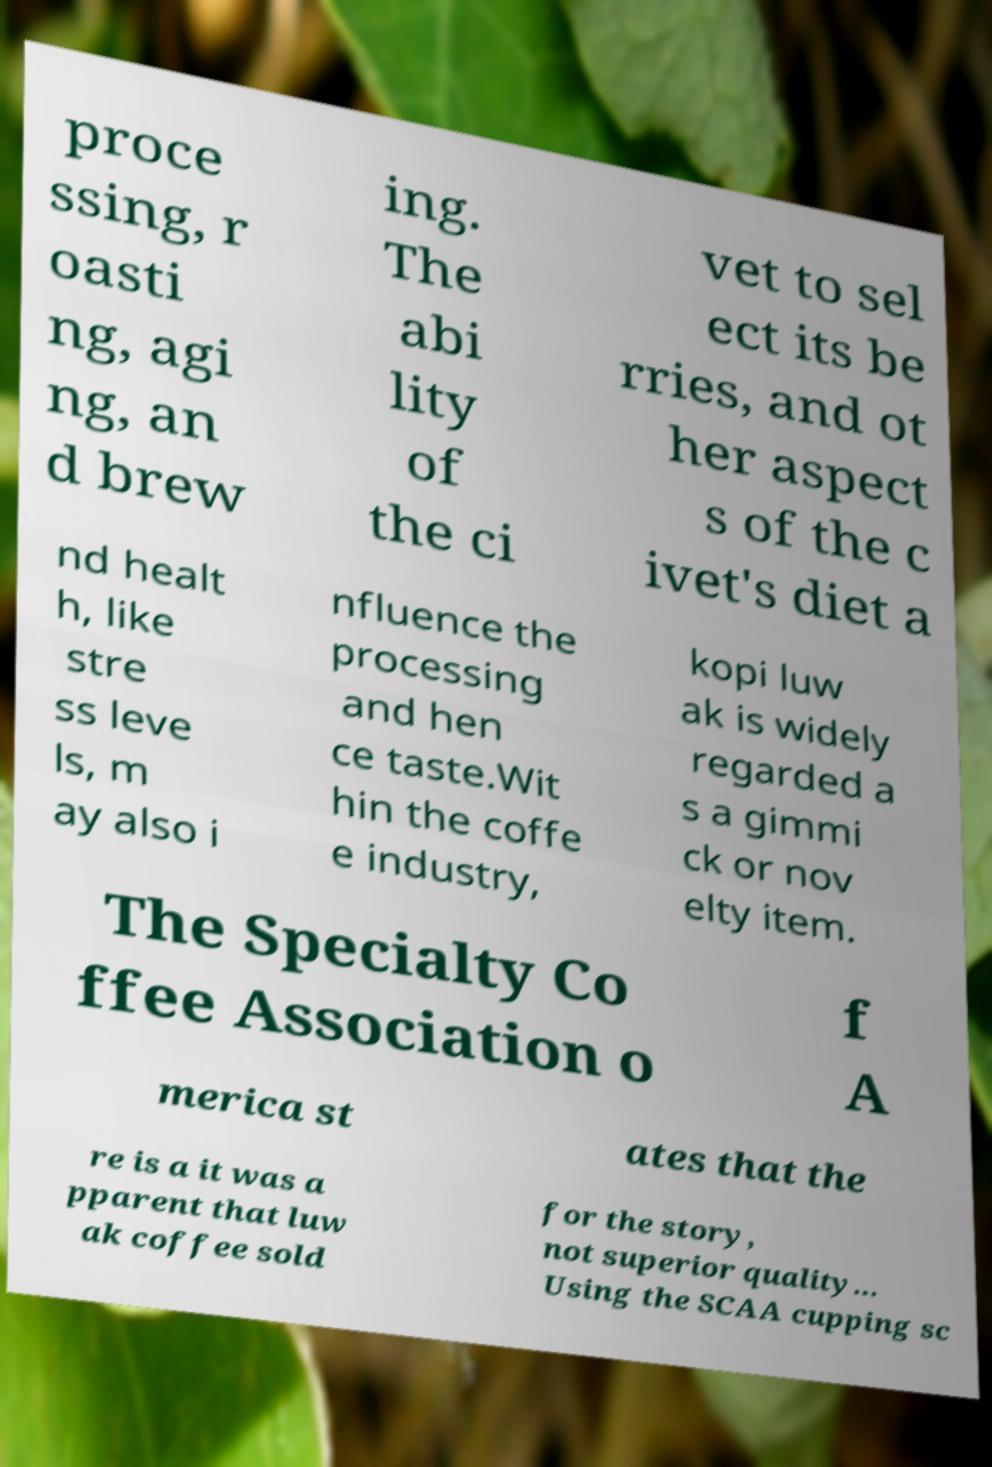Can you read and provide the text displayed in the image?This photo seems to have some interesting text. Can you extract and type it out for me? proce ssing, r oasti ng, agi ng, an d brew ing. The abi lity of the ci vet to sel ect its be rries, and ot her aspect s of the c ivet's diet a nd healt h, like stre ss leve ls, m ay also i nfluence the processing and hen ce taste.Wit hin the coffe e industry, kopi luw ak is widely regarded a s a gimmi ck or nov elty item. The Specialty Co ffee Association o f A merica st ates that the re is a it was a pparent that luw ak coffee sold for the story, not superior quality... Using the SCAA cupping sc 